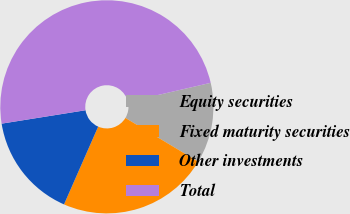Convert chart. <chart><loc_0><loc_0><loc_500><loc_500><pie_chart><fcel>Equity securities<fcel>Fixed maturity securities<fcel>Other investments<fcel>Total<nl><fcel>12.22%<fcel>22.98%<fcel>15.89%<fcel>48.9%<nl></chart> 